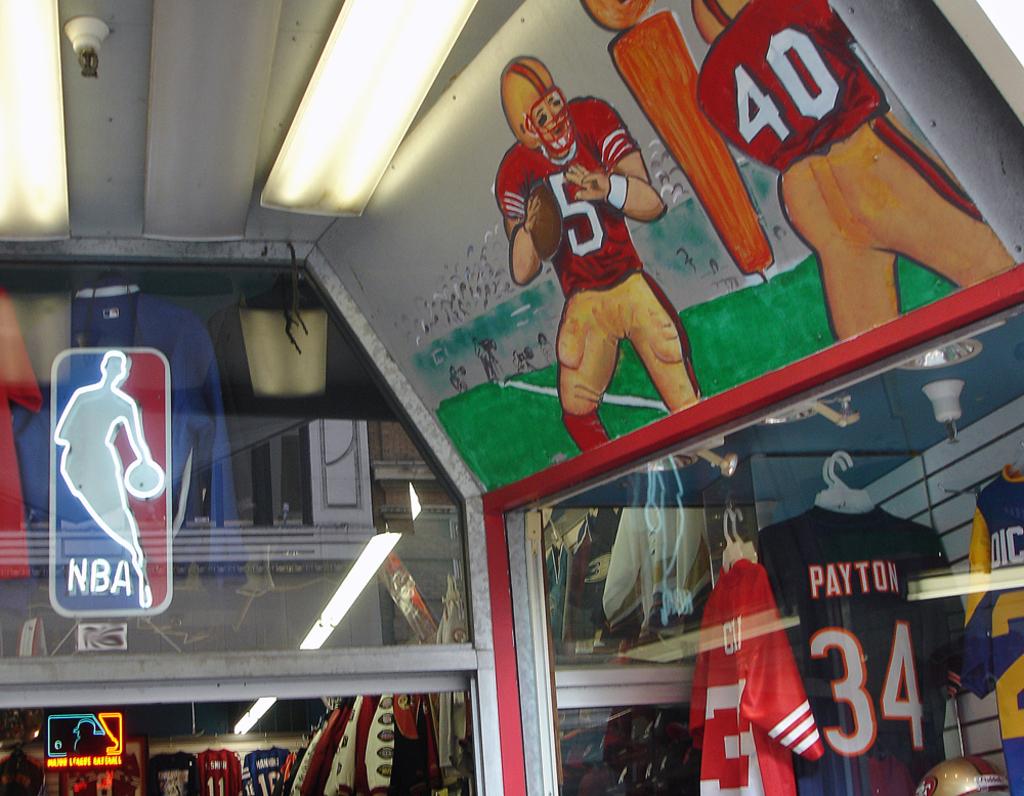What is the number of payton's jersey?
Your answer should be compact. 34. Is that the nba sign?
Offer a very short reply. Yes. 